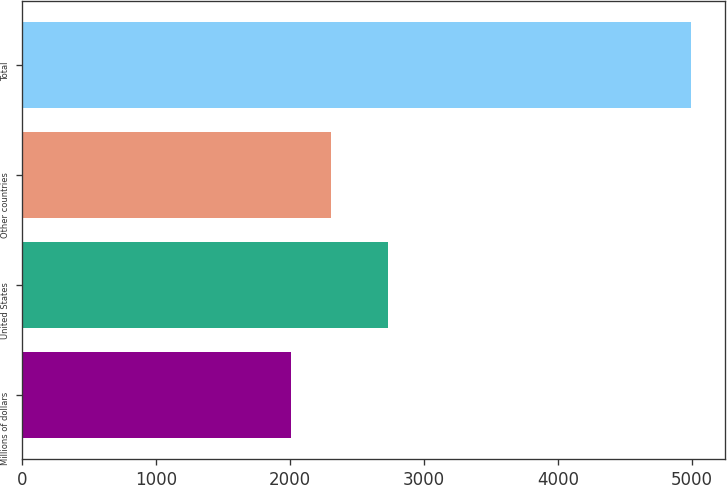Convert chart. <chart><loc_0><loc_0><loc_500><loc_500><bar_chart><fcel>Millions of dollars<fcel>United States<fcel>Other countries<fcel>Total<nl><fcel>2007<fcel>2733<fcel>2305.9<fcel>4996<nl></chart> 